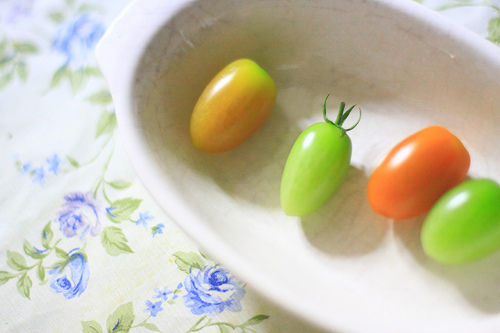<image>
Is the tomatoe on the table? No. The tomatoe is not positioned on the table. They may be near each other, but the tomatoe is not supported by or resting on top of the table. Is there a tablecloth on the tomato? No. The tablecloth is not positioned on the tomato. They may be near each other, but the tablecloth is not supported by or resting on top of the tomato. 